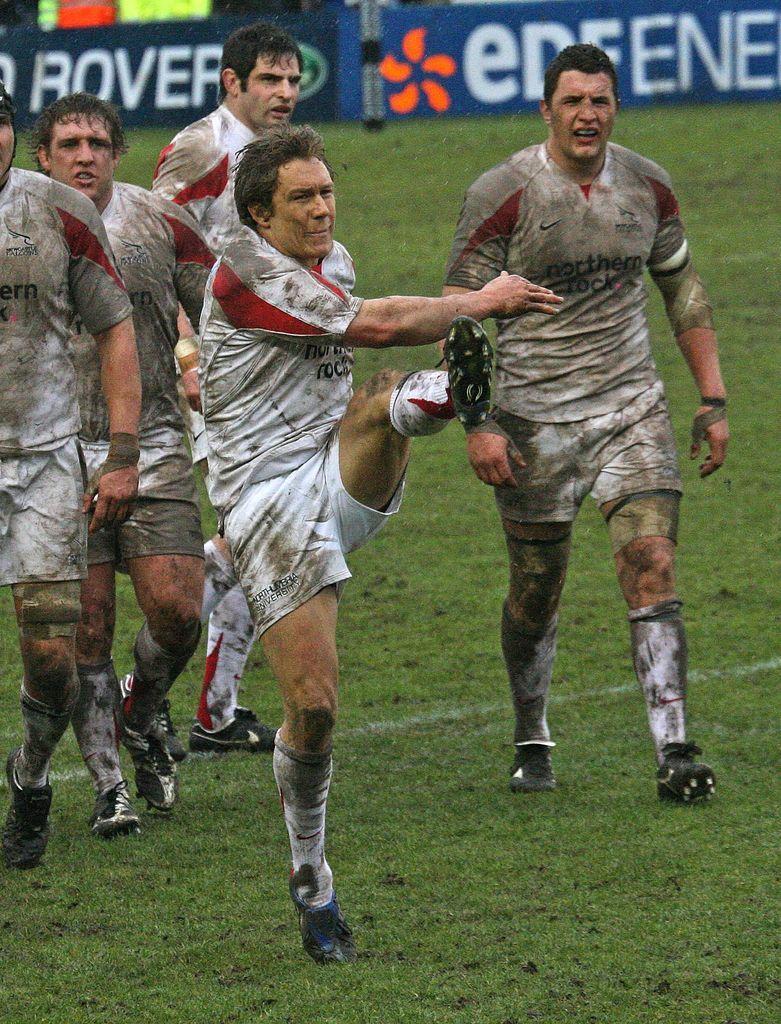Describe this image in one or two sentences. In this image we can see a few people on the ground and in the background, we can see the boards with some text. 